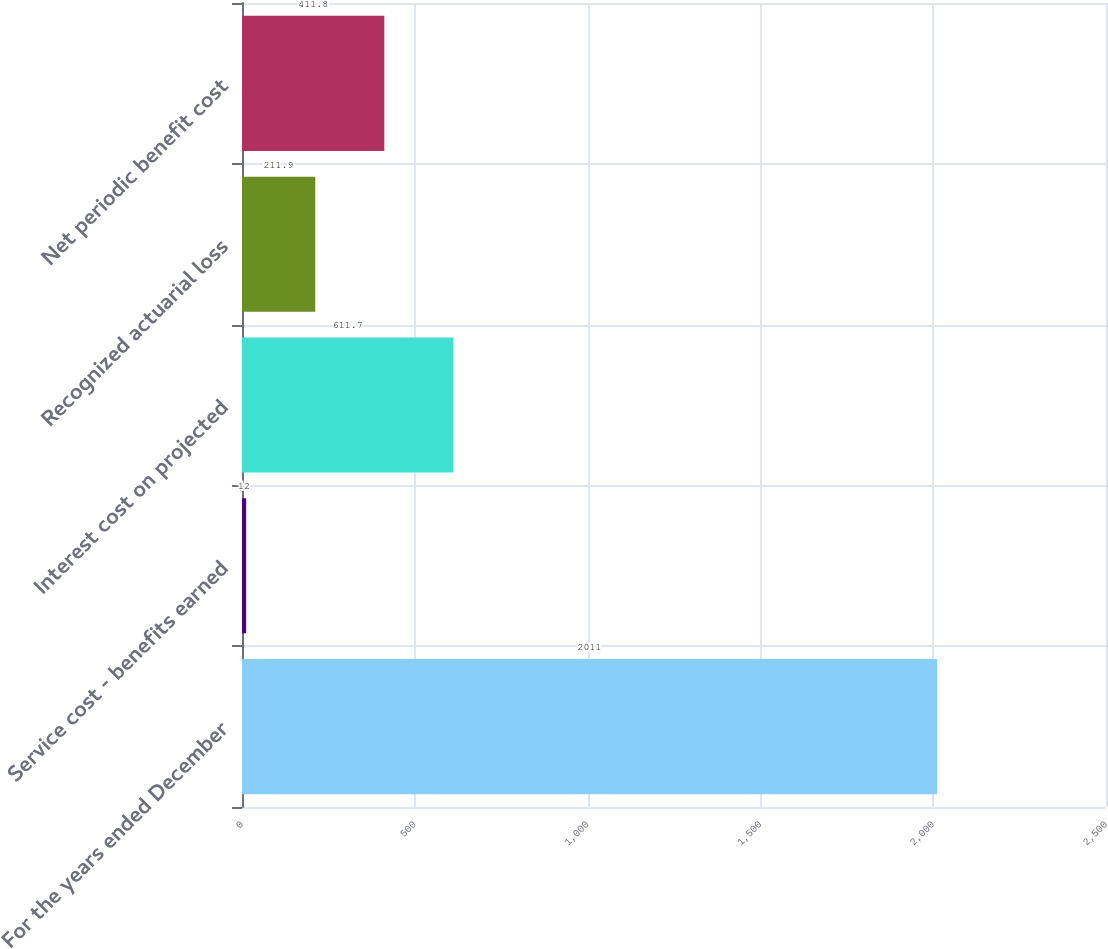<chart> <loc_0><loc_0><loc_500><loc_500><bar_chart><fcel>For the years ended December<fcel>Service cost - benefits earned<fcel>Interest cost on projected<fcel>Recognized actuarial loss<fcel>Net periodic benefit cost<nl><fcel>2011<fcel>12<fcel>611.7<fcel>211.9<fcel>411.8<nl></chart> 